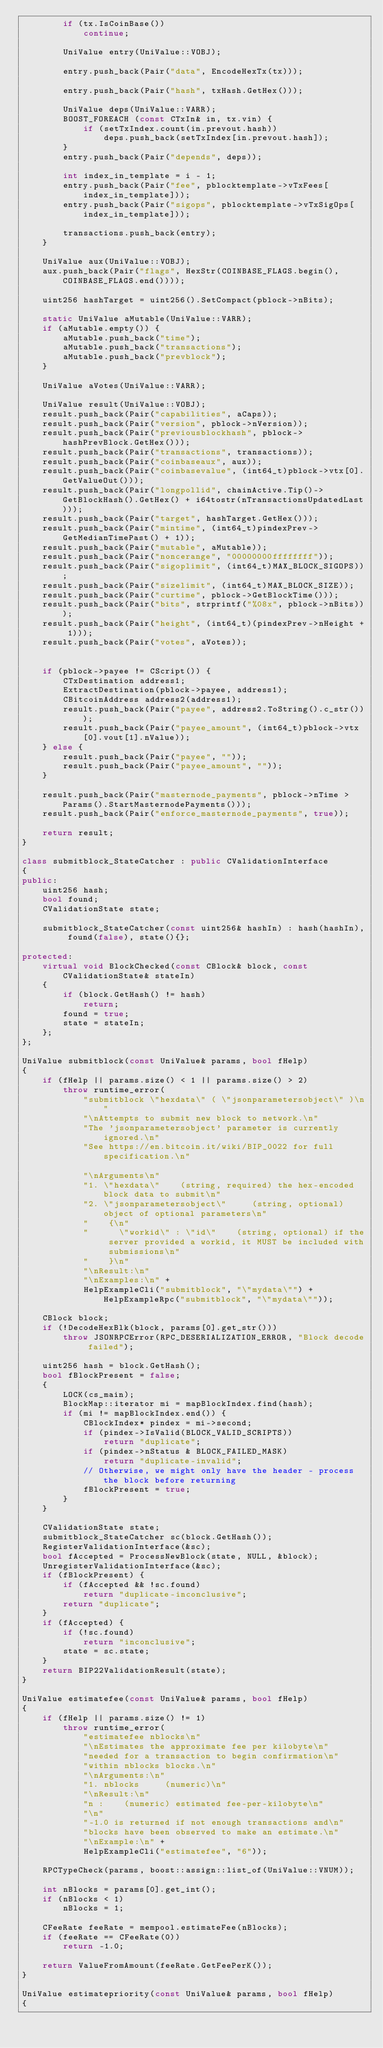<code> <loc_0><loc_0><loc_500><loc_500><_C++_>        if (tx.IsCoinBase())
            continue;

        UniValue entry(UniValue::VOBJ);

        entry.push_back(Pair("data", EncodeHexTx(tx)));

        entry.push_back(Pair("hash", txHash.GetHex()));

        UniValue deps(UniValue::VARR);
        BOOST_FOREACH (const CTxIn& in, tx.vin) {
            if (setTxIndex.count(in.prevout.hash))
                deps.push_back(setTxIndex[in.prevout.hash]);
        }
        entry.push_back(Pair("depends", deps));

        int index_in_template = i - 1;
        entry.push_back(Pair("fee", pblocktemplate->vTxFees[index_in_template]));
        entry.push_back(Pair("sigops", pblocktemplate->vTxSigOps[index_in_template]));

        transactions.push_back(entry);
    }

    UniValue aux(UniValue::VOBJ);
    aux.push_back(Pair("flags", HexStr(COINBASE_FLAGS.begin(), COINBASE_FLAGS.end())));

    uint256 hashTarget = uint256().SetCompact(pblock->nBits);

    static UniValue aMutable(UniValue::VARR);
    if (aMutable.empty()) {
        aMutable.push_back("time");
        aMutable.push_back("transactions");
        aMutable.push_back("prevblock");
    }

    UniValue aVotes(UniValue::VARR);

    UniValue result(UniValue::VOBJ);
    result.push_back(Pair("capabilities", aCaps));
    result.push_back(Pair("version", pblock->nVersion));
    result.push_back(Pair("previousblockhash", pblock->hashPrevBlock.GetHex()));
    result.push_back(Pair("transactions", transactions));
    result.push_back(Pair("coinbaseaux", aux));
    result.push_back(Pair("coinbasevalue", (int64_t)pblock->vtx[0].GetValueOut()));
    result.push_back(Pair("longpollid", chainActive.Tip()->GetBlockHash().GetHex() + i64tostr(nTransactionsUpdatedLast)));
    result.push_back(Pair("target", hashTarget.GetHex()));
    result.push_back(Pair("mintime", (int64_t)pindexPrev->GetMedianTimePast() + 1));
    result.push_back(Pair("mutable", aMutable));
    result.push_back(Pair("noncerange", "00000000ffffffff"));
    result.push_back(Pair("sigoplimit", (int64_t)MAX_BLOCK_SIGOPS));
    result.push_back(Pair("sizelimit", (int64_t)MAX_BLOCK_SIZE));
    result.push_back(Pair("curtime", pblock->GetBlockTime()));
    result.push_back(Pair("bits", strprintf("%08x", pblock->nBits)));
    result.push_back(Pair("height", (int64_t)(pindexPrev->nHeight + 1)));
    result.push_back(Pair("votes", aVotes));


    if (pblock->payee != CScript()) {
        CTxDestination address1;
        ExtractDestination(pblock->payee, address1);
        CBitcoinAddress address2(address1);
        result.push_back(Pair("payee", address2.ToString().c_str()));
        result.push_back(Pair("payee_amount", (int64_t)pblock->vtx[0].vout[1].nValue));
    } else {
        result.push_back(Pair("payee", ""));
        result.push_back(Pair("payee_amount", ""));
    }

    result.push_back(Pair("masternode_payments", pblock->nTime > Params().StartMasternodePayments()));
    result.push_back(Pair("enforce_masternode_payments", true));

    return result;
}

class submitblock_StateCatcher : public CValidationInterface
{
public:
    uint256 hash;
    bool found;
    CValidationState state;

    submitblock_StateCatcher(const uint256& hashIn) : hash(hashIn), found(false), state(){};

protected:
    virtual void BlockChecked(const CBlock& block, const CValidationState& stateIn)
    {
        if (block.GetHash() != hash)
            return;
        found = true;
        state = stateIn;
    };
};

UniValue submitblock(const UniValue& params, bool fHelp)
{
    if (fHelp || params.size() < 1 || params.size() > 2)
        throw runtime_error(
            "submitblock \"hexdata\" ( \"jsonparametersobject\" )\n"
            "\nAttempts to submit new block to network.\n"
            "The 'jsonparametersobject' parameter is currently ignored.\n"
            "See https://en.bitcoin.it/wiki/BIP_0022 for full specification.\n"

            "\nArguments\n"
            "1. \"hexdata\"    (string, required) the hex-encoded block data to submit\n"
            "2. \"jsonparametersobject\"     (string, optional) object of optional parameters\n"
            "    {\n"
            "      \"workid\" : \"id\"    (string, optional) if the server provided a workid, it MUST be included with submissions\n"
            "    }\n"
            "\nResult:\n"
            "\nExamples:\n" +
            HelpExampleCli("submitblock", "\"mydata\"") + HelpExampleRpc("submitblock", "\"mydata\""));

    CBlock block;
    if (!DecodeHexBlk(block, params[0].get_str()))
        throw JSONRPCError(RPC_DESERIALIZATION_ERROR, "Block decode failed");

    uint256 hash = block.GetHash();
    bool fBlockPresent = false;
    {
        LOCK(cs_main);
        BlockMap::iterator mi = mapBlockIndex.find(hash);
        if (mi != mapBlockIndex.end()) {
            CBlockIndex* pindex = mi->second;
            if (pindex->IsValid(BLOCK_VALID_SCRIPTS))
                return "duplicate";
            if (pindex->nStatus & BLOCK_FAILED_MASK)
                return "duplicate-invalid";
            // Otherwise, we might only have the header - process the block before returning
            fBlockPresent = true;
        }
    }

    CValidationState state;
    submitblock_StateCatcher sc(block.GetHash());
    RegisterValidationInterface(&sc);
    bool fAccepted = ProcessNewBlock(state, NULL, &block);
    UnregisterValidationInterface(&sc);
    if (fBlockPresent) {
        if (fAccepted && !sc.found)
            return "duplicate-inconclusive";
        return "duplicate";
    }
    if (fAccepted) {
        if (!sc.found)
            return "inconclusive";
        state = sc.state;
    }
    return BIP22ValidationResult(state);
}

UniValue estimatefee(const UniValue& params, bool fHelp)
{
    if (fHelp || params.size() != 1)
        throw runtime_error(
            "estimatefee nblocks\n"
            "\nEstimates the approximate fee per kilobyte\n"
            "needed for a transaction to begin confirmation\n"
            "within nblocks blocks.\n"
            "\nArguments:\n"
            "1. nblocks     (numeric)\n"
            "\nResult:\n"
            "n :    (numeric) estimated fee-per-kilobyte\n"
            "\n"
            "-1.0 is returned if not enough transactions and\n"
            "blocks have been observed to make an estimate.\n"
            "\nExample:\n" +
            HelpExampleCli("estimatefee", "6"));

    RPCTypeCheck(params, boost::assign::list_of(UniValue::VNUM));

    int nBlocks = params[0].get_int();
    if (nBlocks < 1)
        nBlocks = 1;

    CFeeRate feeRate = mempool.estimateFee(nBlocks);
    if (feeRate == CFeeRate(0))
        return -1.0;

    return ValueFromAmount(feeRate.GetFeePerK());
}

UniValue estimatepriority(const UniValue& params, bool fHelp)
{</code> 